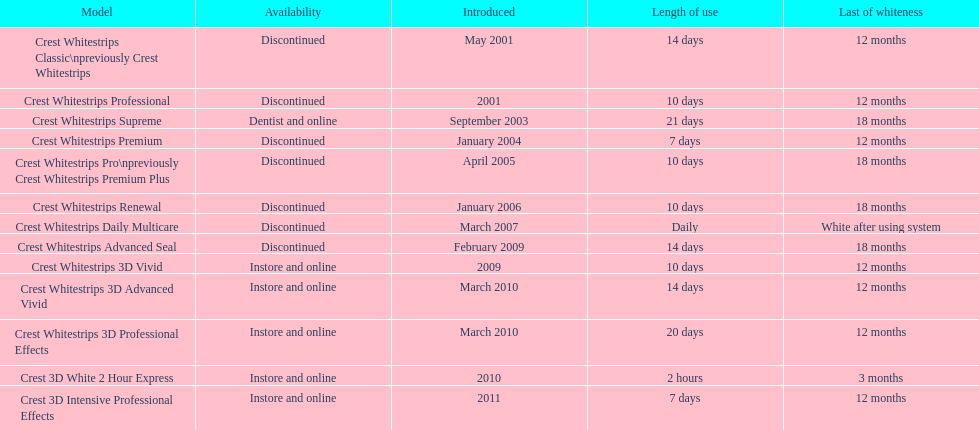Which model exhibits the maximum 'length of utilization' to 'conclusion of whiteness' relationship? Crest Whitestrips Supreme. 